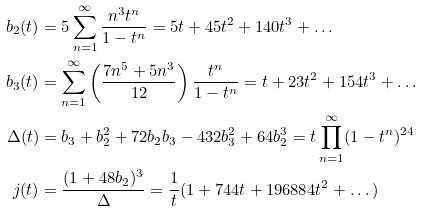<formula> <loc_0><loc_0><loc_500><loc_500>b _ { 2 } ( t ) & = 5 \sum _ { n = 1 } ^ { \infty } \frac { n ^ { 3 } t ^ { n } } { 1 - t ^ { n } } = 5 t + 4 5 t ^ { 2 } + 1 4 0 t ^ { 3 } + \dots \\ b _ { 3 } ( t ) & = \sum _ { n = 1 } ^ { \infty } \left ( \frac { 7 n ^ { 5 } + 5 n ^ { 3 } } { 1 2 } \right ) \frac { t ^ { n } } { 1 - t ^ { n } } = t + 2 3 t ^ { 2 } + 1 5 4 t ^ { 3 } + \dots \\ \Delta ( t ) & = b _ { 3 } + b _ { 2 } ^ { 2 } + 7 2 b _ { 2 } b _ { 3 } - 4 3 2 b _ { 3 } ^ { 2 } + 6 4 b _ { 2 } ^ { 3 } = t \prod _ { n = 1 } ^ { \infty } ( 1 - t ^ { n } ) ^ { 2 4 } \\ j ( t ) & = \frac { ( 1 + 4 8 b _ { 2 } ) ^ { 3 } } { \Delta } = \frac { 1 } { t } ( 1 + 7 4 4 t + 1 9 6 8 8 4 t ^ { 2 } + \dots )</formula> 